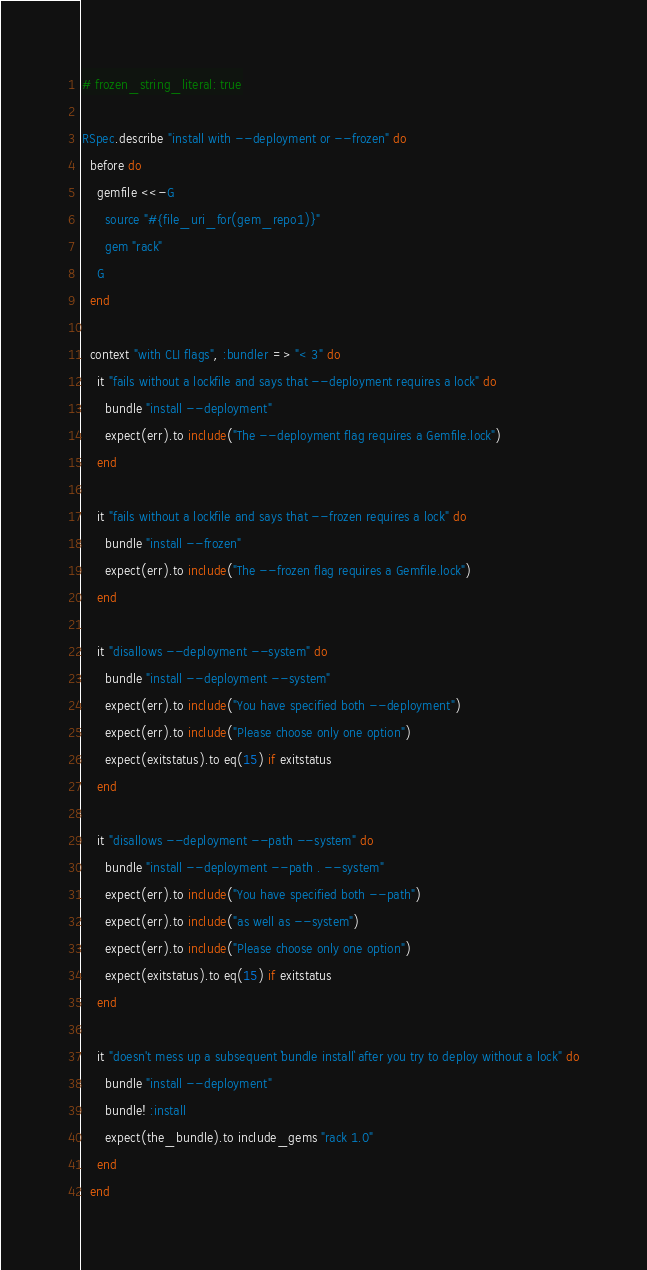Convert code to text. <code><loc_0><loc_0><loc_500><loc_500><_Ruby_># frozen_string_literal: true

RSpec.describe "install with --deployment or --frozen" do
  before do
    gemfile <<-G
      source "#{file_uri_for(gem_repo1)}"
      gem "rack"
    G
  end

  context "with CLI flags", :bundler => "< 3" do
    it "fails without a lockfile and says that --deployment requires a lock" do
      bundle "install --deployment"
      expect(err).to include("The --deployment flag requires a Gemfile.lock")
    end

    it "fails without a lockfile and says that --frozen requires a lock" do
      bundle "install --frozen"
      expect(err).to include("The --frozen flag requires a Gemfile.lock")
    end

    it "disallows --deployment --system" do
      bundle "install --deployment --system"
      expect(err).to include("You have specified both --deployment")
      expect(err).to include("Please choose only one option")
      expect(exitstatus).to eq(15) if exitstatus
    end

    it "disallows --deployment --path --system" do
      bundle "install --deployment --path . --system"
      expect(err).to include("You have specified both --path")
      expect(err).to include("as well as --system")
      expect(err).to include("Please choose only one option")
      expect(exitstatus).to eq(15) if exitstatus
    end

    it "doesn't mess up a subsequent `bundle install` after you try to deploy without a lock" do
      bundle "install --deployment"
      bundle! :install
      expect(the_bundle).to include_gems "rack 1.0"
    end
  end
</code> 